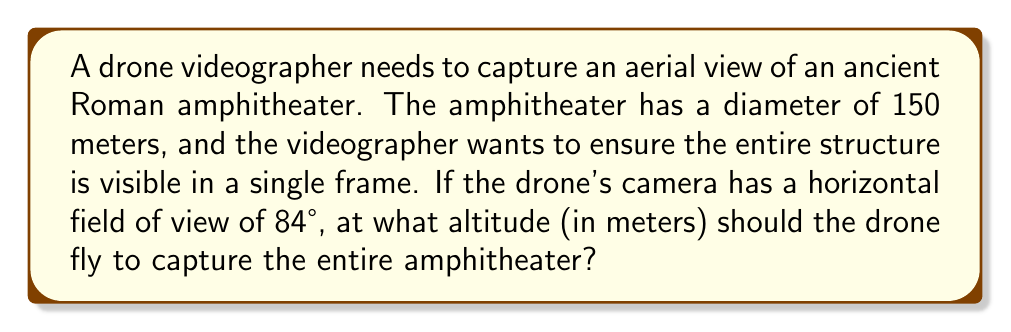Could you help me with this problem? To solve this problem, we'll use trigonometry. Let's break it down step-by-step:

1) First, we need to understand the relationship between the drone's altitude, the field of view, and the size of the area captured.

2) The horizontal field of view forms an isosceles triangle, with the drone at the apex and the diameter of the amphitheater as the base.

3) We can split this isosceles triangle into two right triangles. Let's focus on one of these right triangles.

4) In this right triangle:
   - The adjacent side is the drone's altitude (let's call it h)
   - Half of the amphitheater's diameter (75 m) is the opposite side
   - Half of the camera's field of view (84°/2 = 42°) is the angle between the adjacent side and the hypotenuse

5) We can use the tangent function to relate these:

   $$\tan(42°) = \frac{75}{h}$$

6) To solve for h, we rearrange the equation:

   $$h = \frac{75}{\tan(42°)}$$

7) Now we can calculate:
   
   $$h = \frac{75}{\tan(42°)} \approx 83.86\text{ meters}$$

8) Rounding up to ensure the entire amphitheater is captured, we get 84 meters.

[asy]
import geometry;

pair A = (0,0), B = (150,0), C = (75,84);
draw(A--B--C--A);
draw(C--(75,0),dashed);

label("150 m", (75,0), S);
label("84 m", (80,42), E);
label("42°", C, NE);
label("Drone", C, N);
label("Amphitheater", (75,0), S);

dot(C);
[/asy]
Answer: 84 meters 